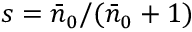<formula> <loc_0><loc_0><loc_500><loc_500>s = \bar { n } _ { 0 } / ( \bar { n } _ { 0 } + 1 )</formula> 